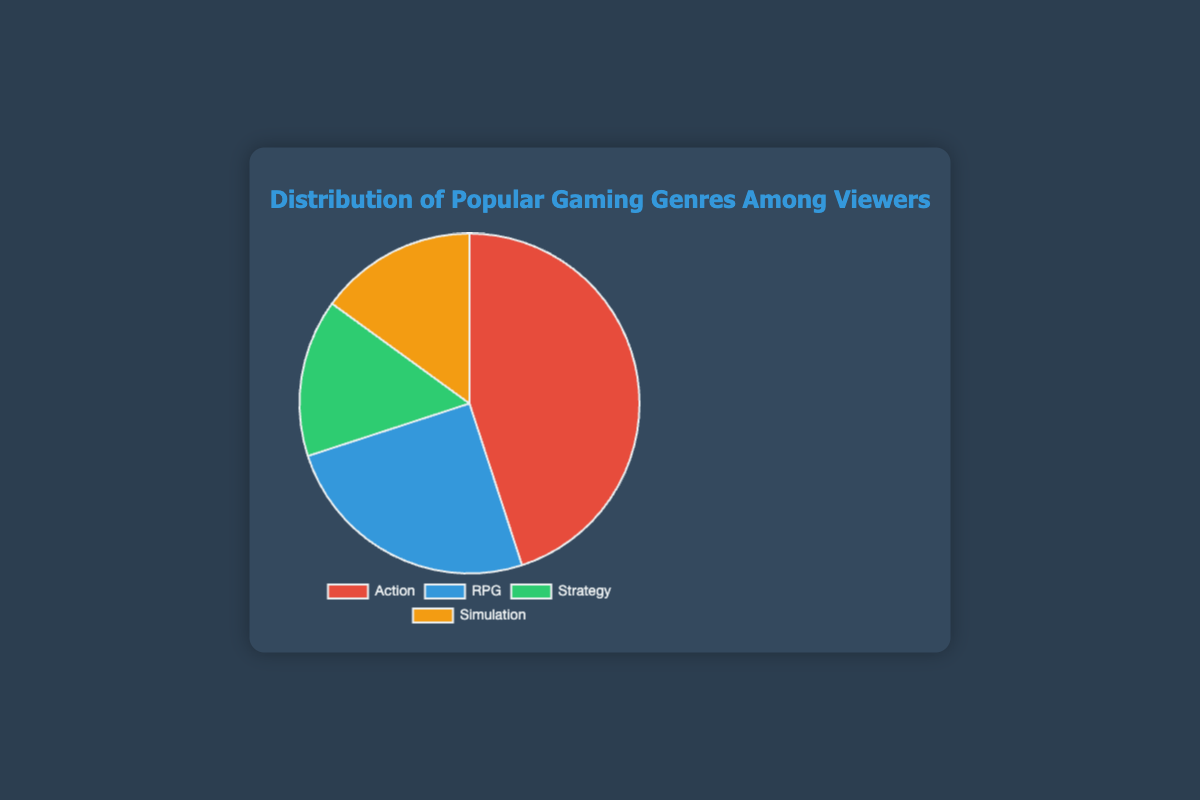Which gaming genre has the highest viewership? Action has the highest viewership. The data shows that Action has a viewership of 45%, which is greater than any other genre.
Answer: Action Which genre has the lowest viewership? Both Strategy and Simulation have the lowest viewership. The data shows that both Strategy and Simulation have a viewership of 15%, which is the lowest among the genres.
Answer: Strategy and Simulation How much more viewership does the Action genre have compared to the RPG genre? The Action genre has 45% viewership and the RPG genre has 25%. The difference in viewership is 45% - 25% = 20%.
Answer: 20% What is the combined viewership percentage of the Strategy and Simulation genres? The Strategy and Simulation genres each have a viewership of 15%. Combined, their viewership is 15% + 15% = 30%.
Answer: 30% If we sum the viewership percentages of RPG, Strategy, and Simulation genres, what will it be? The RPG genre has 25% viewership, while both Strategy and Simulation have 15% each. Summing these, we get 25% + 15% + 15% = 55%.
Answer: 55% Which genre is represented by the blue section of the pie chart? The blue section of the pie chart represents the RPG genre. The chart labels and coloring show that RPG is assigned the blue color.
Answer: RPG Is the viewership percentage of RPG greater than, less than, or equal to the total viewership of Strategy and Simulation combined? The viewership percentage for RPG is 25%, while the combined viewership for Strategy (15%) and Simulation (15%) is 30%. Therefore, 25% is less than 30%.
Answer: Less than What percentage of the total viewership does the most popular genre represent? The most popular genre is Action, which represents 45% of the total viewership according to the data.
Answer: 45% By how much does the viewership of the most popular genre exceed the total viewership of the least popular genres combined? The most popular genre (Action) has 45% viewership. The least popular genres (Strategy and Simulation) each have 15%, combined they are 15% + 15% = 30%. The difference is 45% - 30% = 15%.
Answer: 15% What is the average viewership percentage across all four gaming genres? The total viewership percentage is 45% (Action) + 25% (RPG) + 15% (Strategy) + 15% (Simulation) = 100%. The average percentage is thus 100% / 4 = 25%.
Answer: 25% 